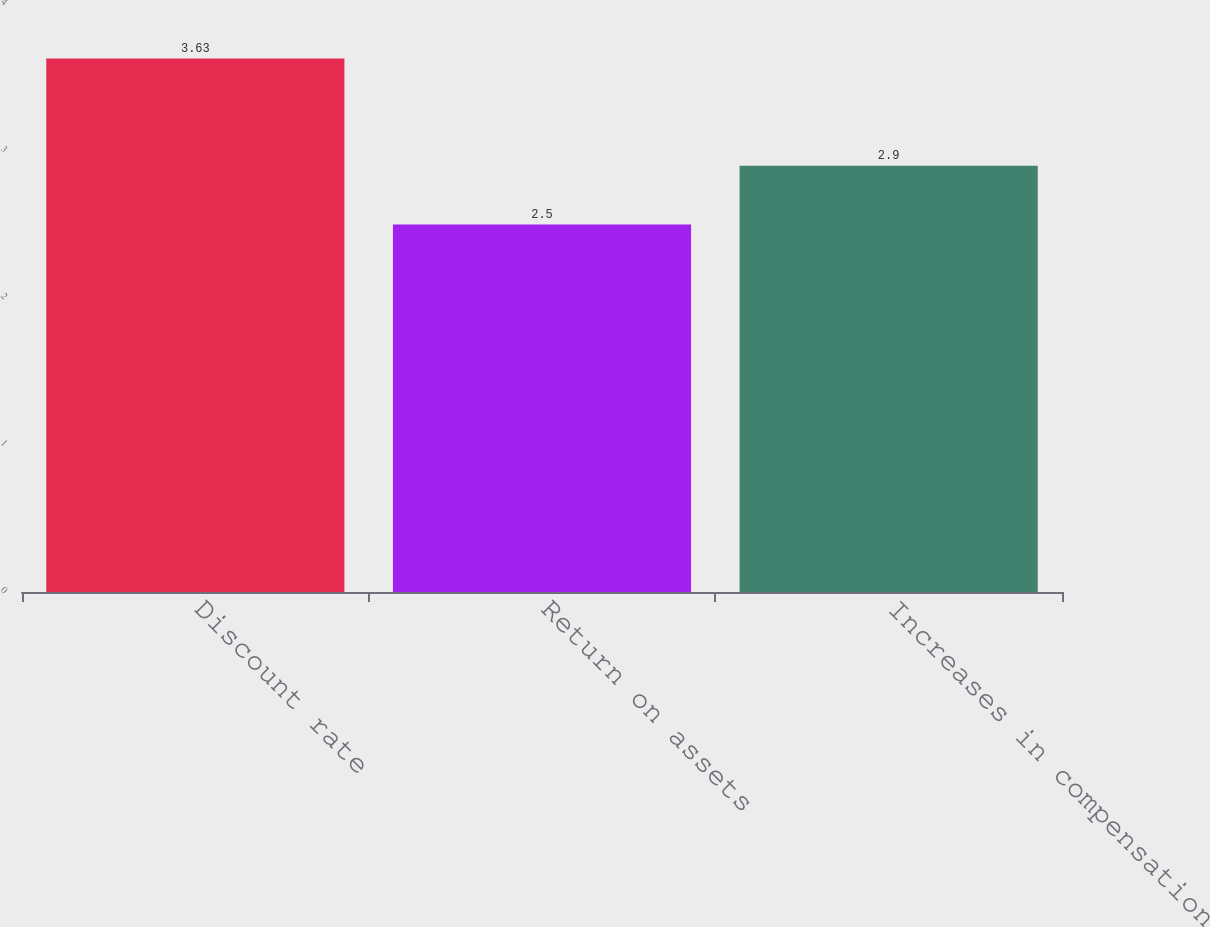Convert chart. <chart><loc_0><loc_0><loc_500><loc_500><bar_chart><fcel>Discount rate<fcel>Return on assets<fcel>Increases in compensation<nl><fcel>3.63<fcel>2.5<fcel>2.9<nl></chart> 